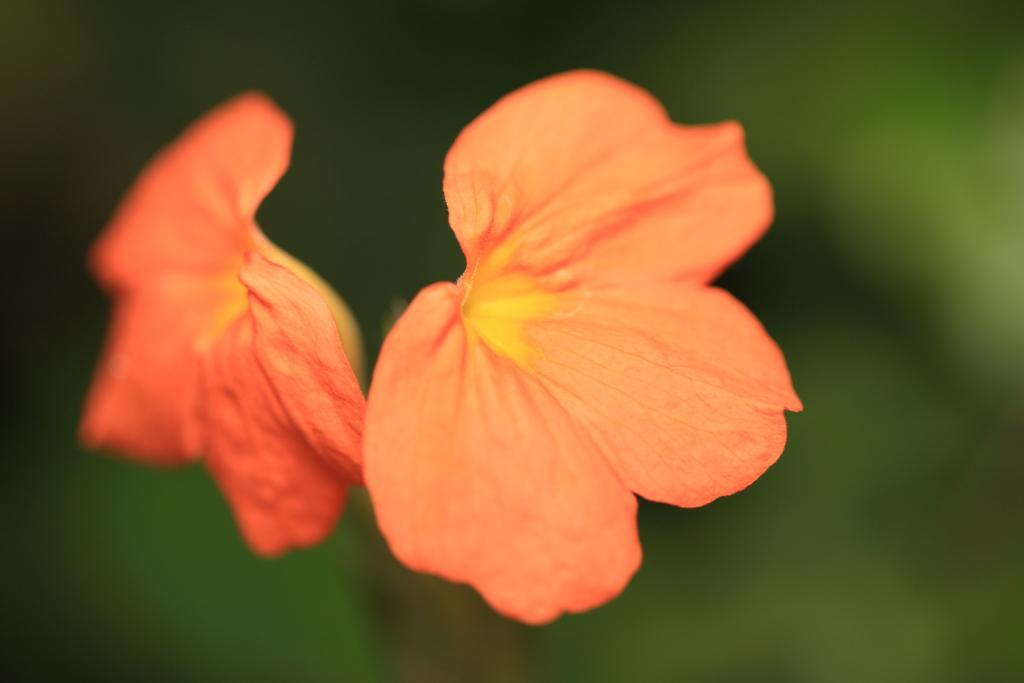How would you summarize this image in a sentence or two? In the foreground of this image, there are two light orange colored flowers and there are leaves around it. 